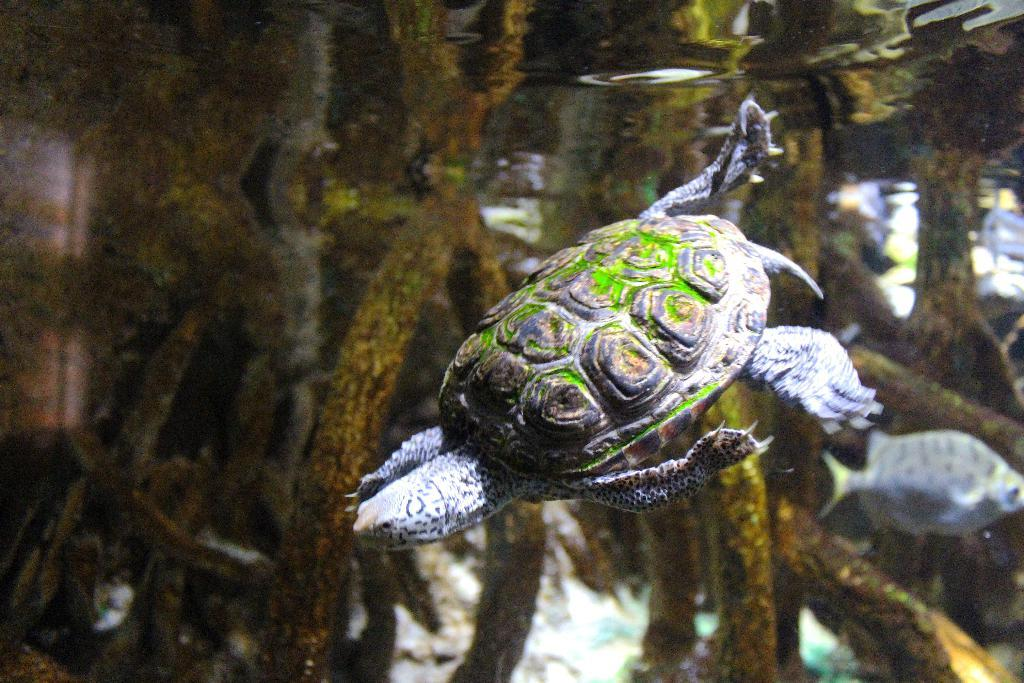What type of animal can be seen in the image? There is a tortoise in the image. What other living creature is present in the image? There is a fish in the image. What can be seen in the background of the image? Underwater plants are visible in the image. What type of rifle is the spy using in the image? There is no rifle or spy present in the image; it features a tortoise and a fish in an underwater environment. 